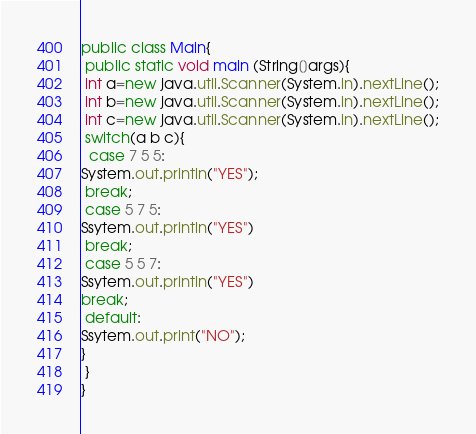Convert code to text. <code><loc_0><loc_0><loc_500><loc_500><_Java_>public class Main{
 public static void main (String[]args){
 int a=new java.util.Scanner(System.in).nextLine();
 int b=new java.util.Scanner(System.in).nextLine();
 int c=new java.util.Scanner(System.in).nextLine();
 switch(a b c){
  case 7 5 5:
System.out.println("YES");
 break;
 case 5 7 5:
Ssytem.out.println("YES")
 break;
 case 5 5 7:
Ssytem.out.println("YES")
break;
 default:
Ssytem.out.print("NO");
}
 }
}</code> 